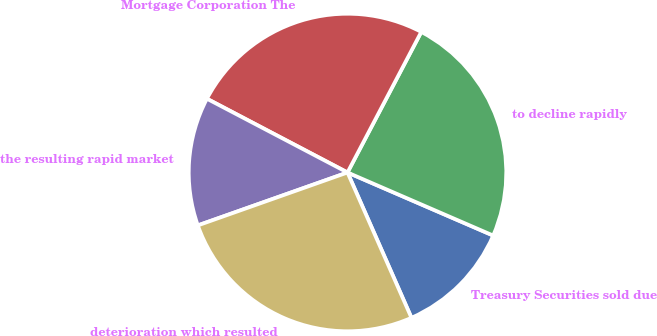<chart> <loc_0><loc_0><loc_500><loc_500><pie_chart><fcel>Treasury Securities sold due<fcel>to decline rapidly<fcel>Mortgage Corporation The<fcel>the resulting rapid market<fcel>deterioration which resulted<nl><fcel>11.9%<fcel>23.81%<fcel>25.0%<fcel>13.1%<fcel>26.19%<nl></chart> 